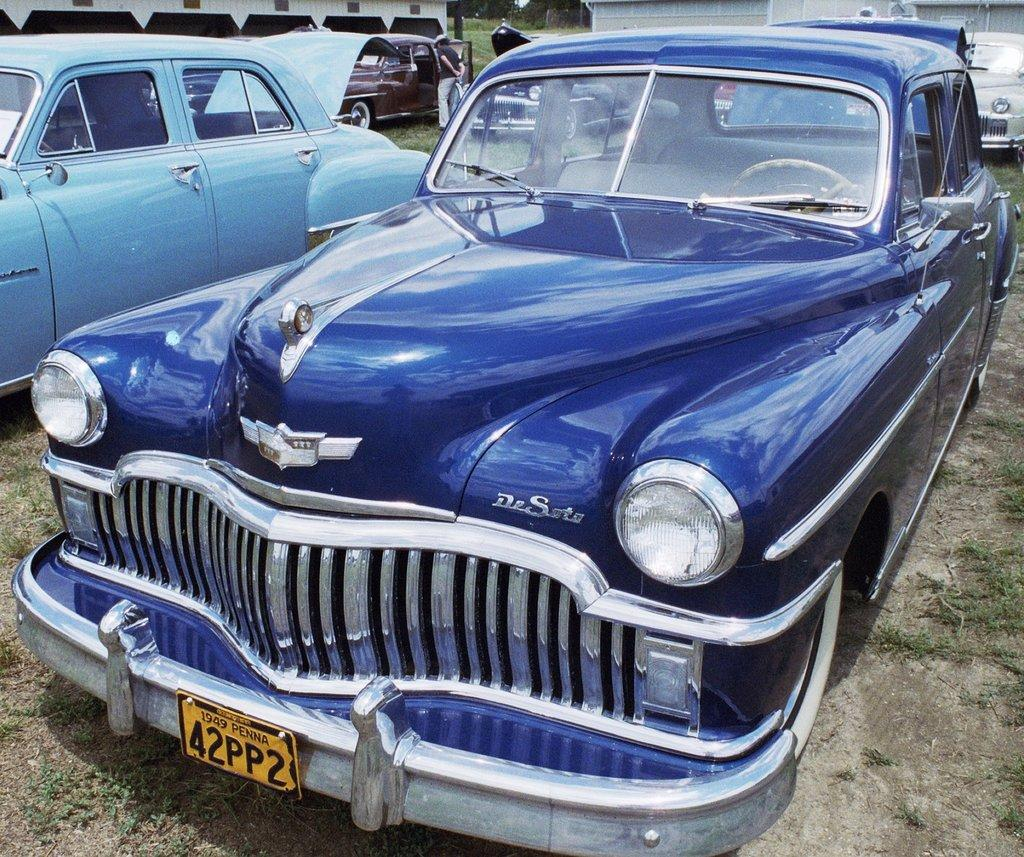What can be seen on the land in the image? There are cars parked on the land in the image. What type of vegetation is visible in the image? There is grass visible in the image. Can you describe the man in the background of the image? There is a man standing in the background of the image. What chess pieces are being used to destroy the grass in the image? There are no chess pieces or destruction present in the image; it features cars parked on the land and grass. What degree of education does the man in the background of the image have? There is no information about the man's education in the image, as it only shows him standing in the background. 